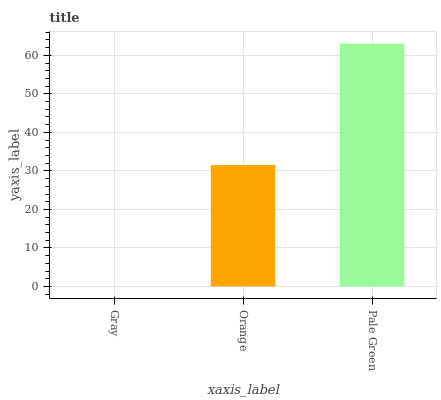Is Gray the minimum?
Answer yes or no. Yes. Is Pale Green the maximum?
Answer yes or no. Yes. Is Orange the minimum?
Answer yes or no. No. Is Orange the maximum?
Answer yes or no. No. Is Orange greater than Gray?
Answer yes or no. Yes. Is Gray less than Orange?
Answer yes or no. Yes. Is Gray greater than Orange?
Answer yes or no. No. Is Orange less than Gray?
Answer yes or no. No. Is Orange the high median?
Answer yes or no. Yes. Is Orange the low median?
Answer yes or no. Yes. Is Pale Green the high median?
Answer yes or no. No. Is Pale Green the low median?
Answer yes or no. No. 